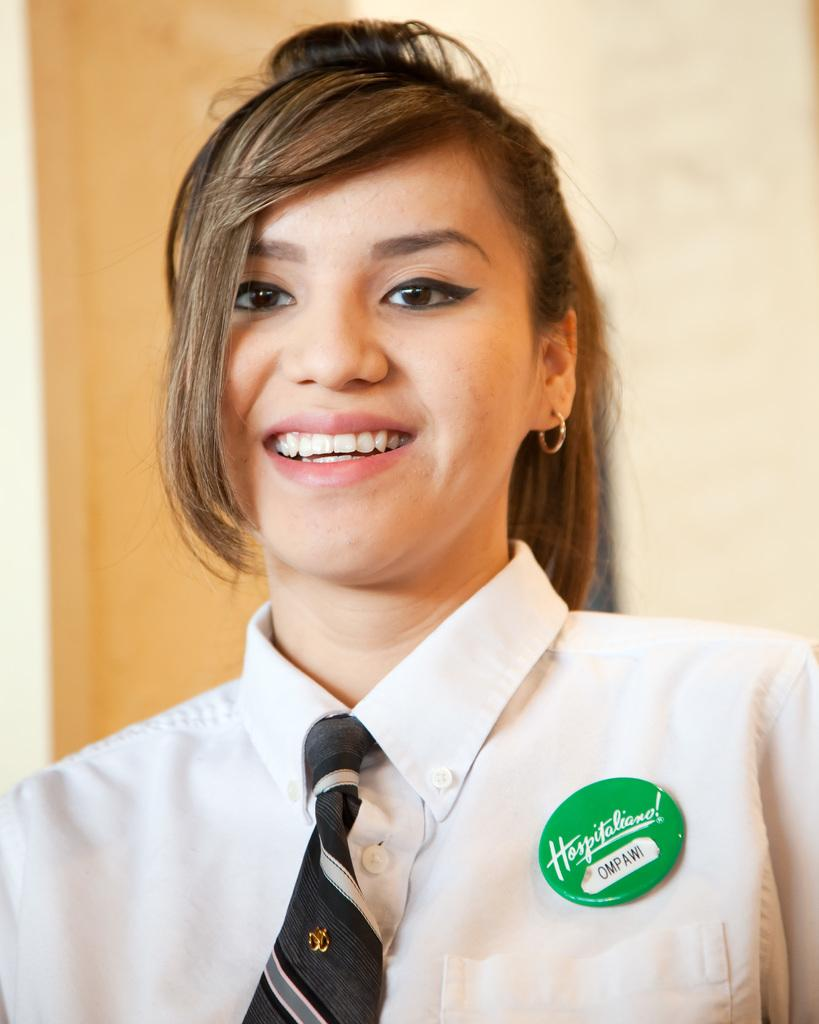<image>
Create a compact narrative representing the image presented. A girl with brown hair smiling and wearing a hospitaliano button 